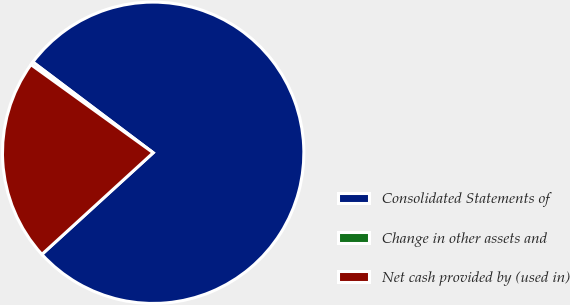<chart> <loc_0><loc_0><loc_500><loc_500><pie_chart><fcel>Consolidated Statements of<fcel>Change in other assets and<fcel>Net cash provided by (used in)<nl><fcel>77.93%<fcel>0.34%<fcel>21.72%<nl></chart> 